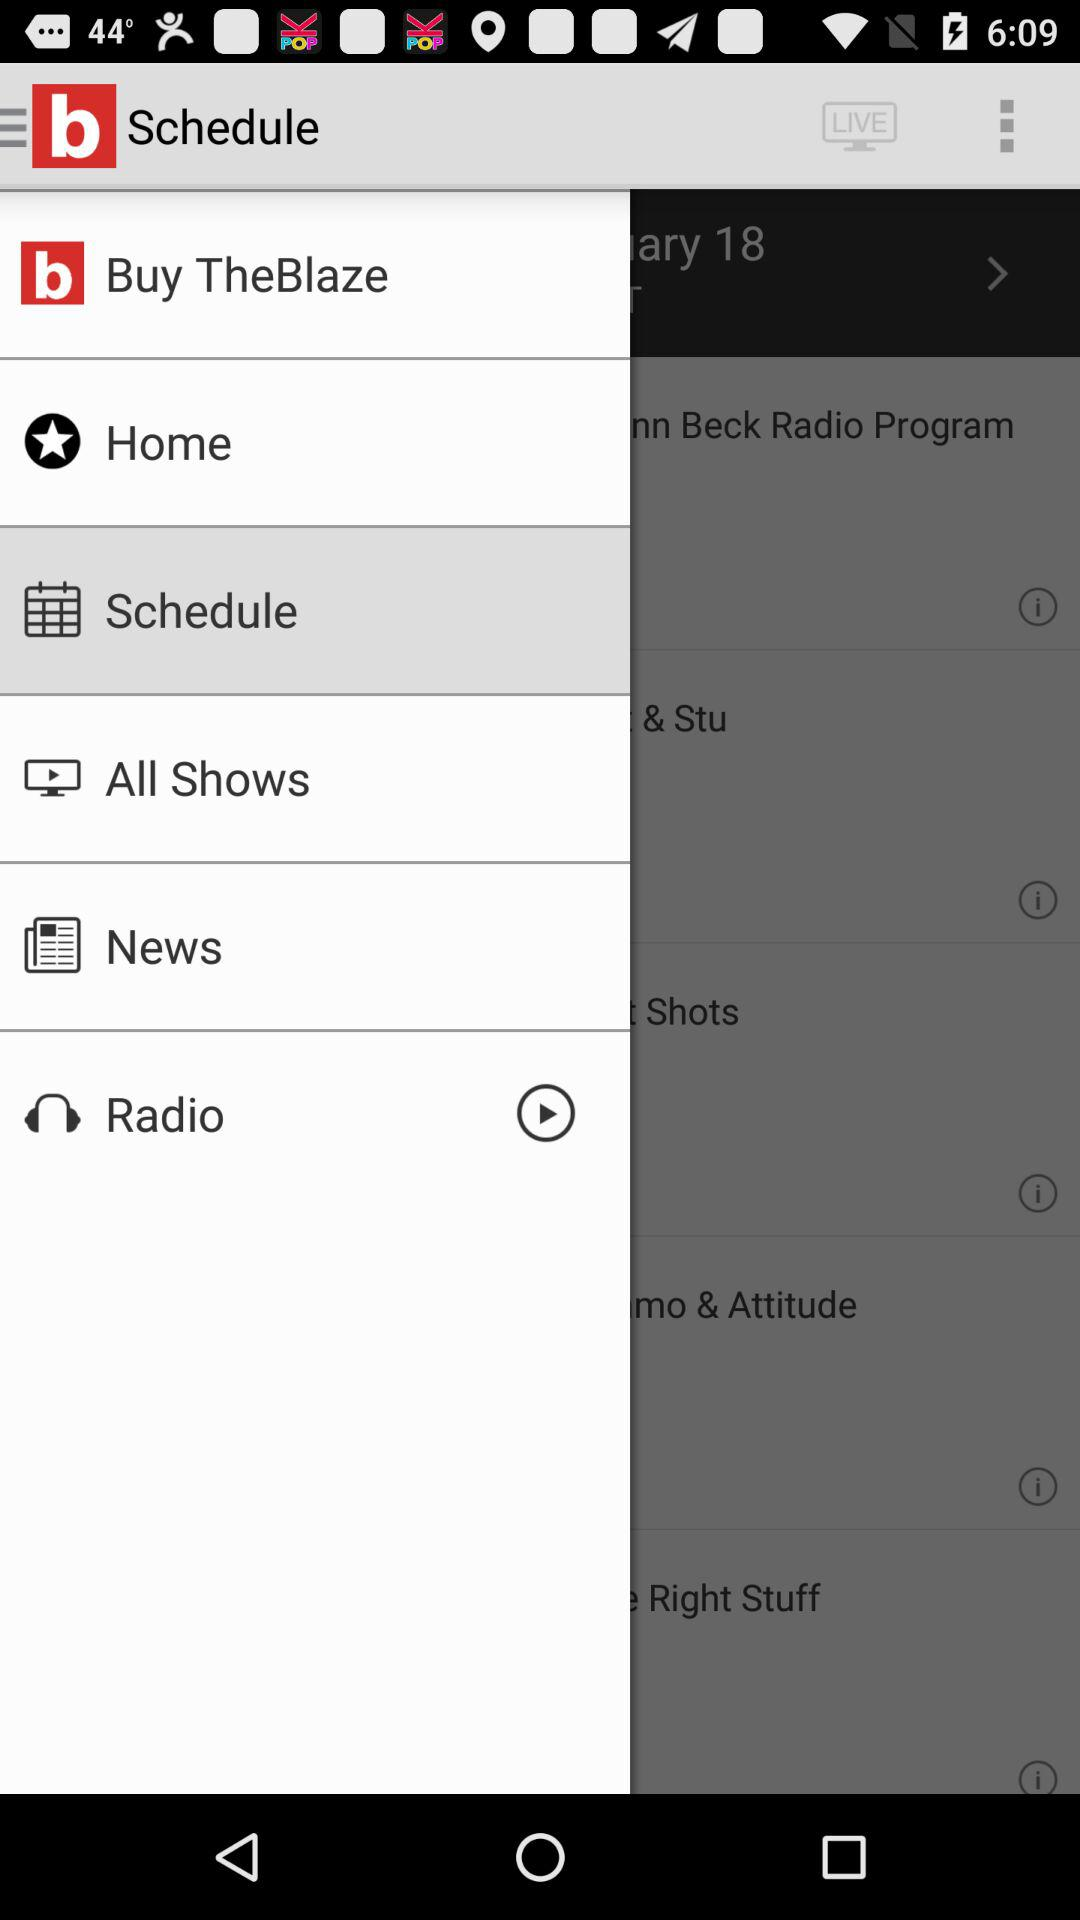What is the application name? The application name is "TheBlaze". 